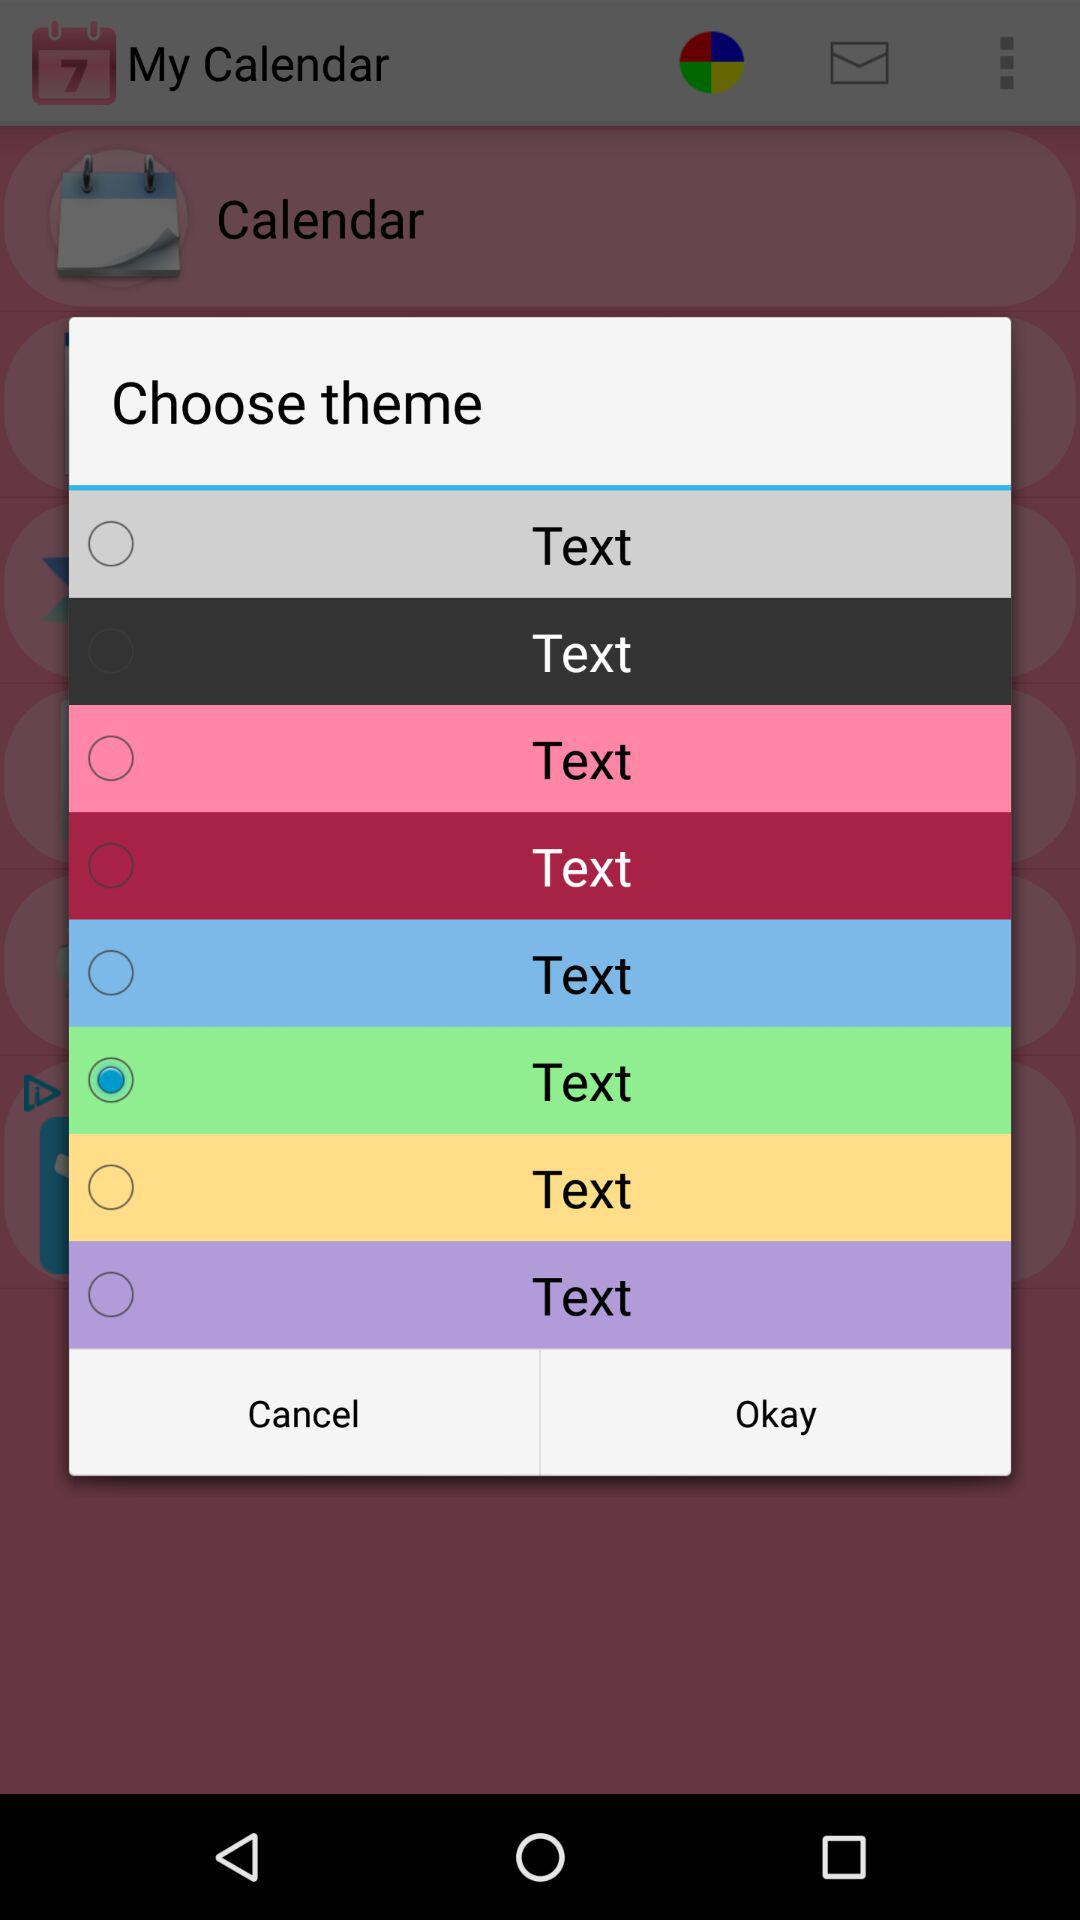Which option is selected? The selected option is "Text". 